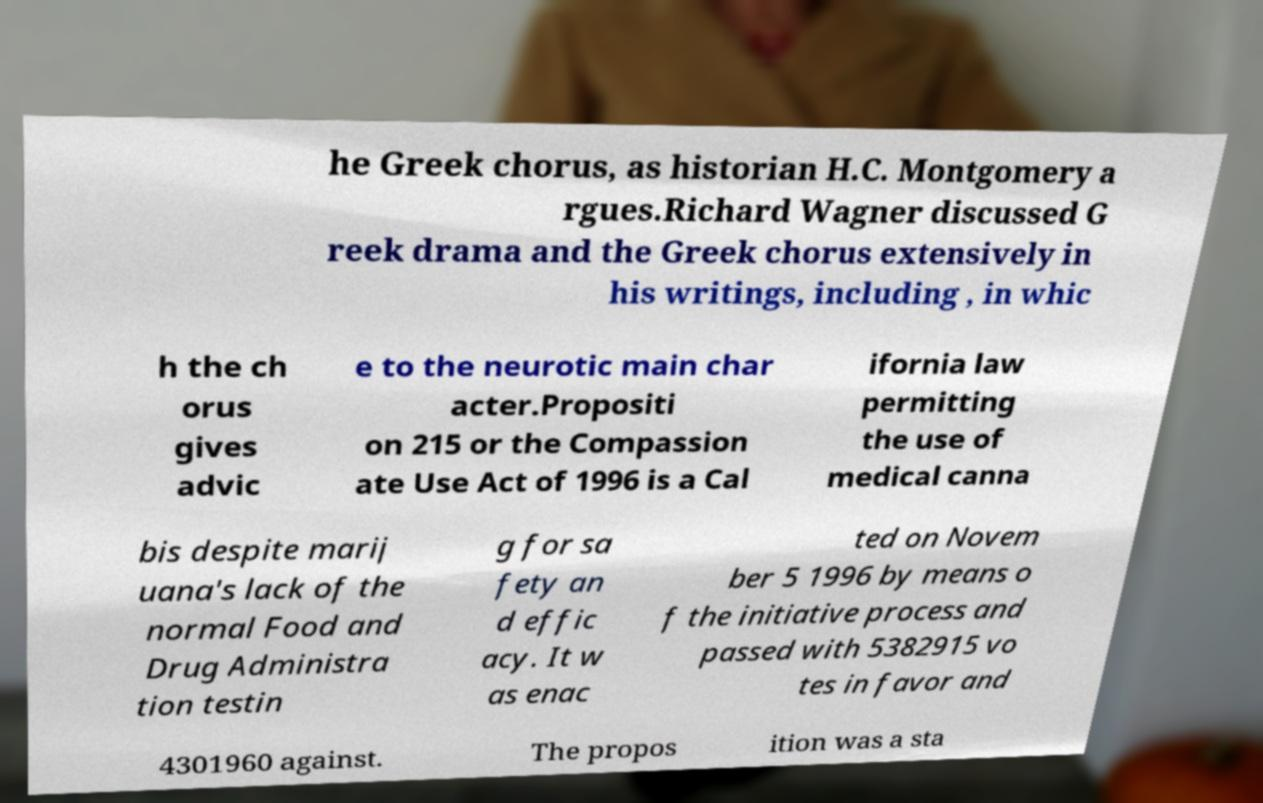Can you read and provide the text displayed in the image?This photo seems to have some interesting text. Can you extract and type it out for me? he Greek chorus, as historian H.C. Montgomery a rgues.Richard Wagner discussed G reek drama and the Greek chorus extensively in his writings, including , in whic h the ch orus gives advic e to the neurotic main char acter.Propositi on 215 or the Compassion ate Use Act of 1996 is a Cal ifornia law permitting the use of medical canna bis despite marij uana's lack of the normal Food and Drug Administra tion testin g for sa fety an d effic acy. It w as enac ted on Novem ber 5 1996 by means o f the initiative process and passed with 5382915 vo tes in favor and 4301960 against. The propos ition was a sta 